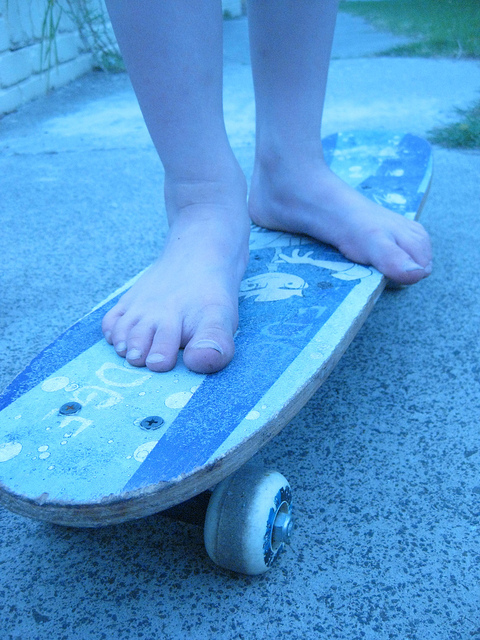Read and extract the text from this image. DGE 